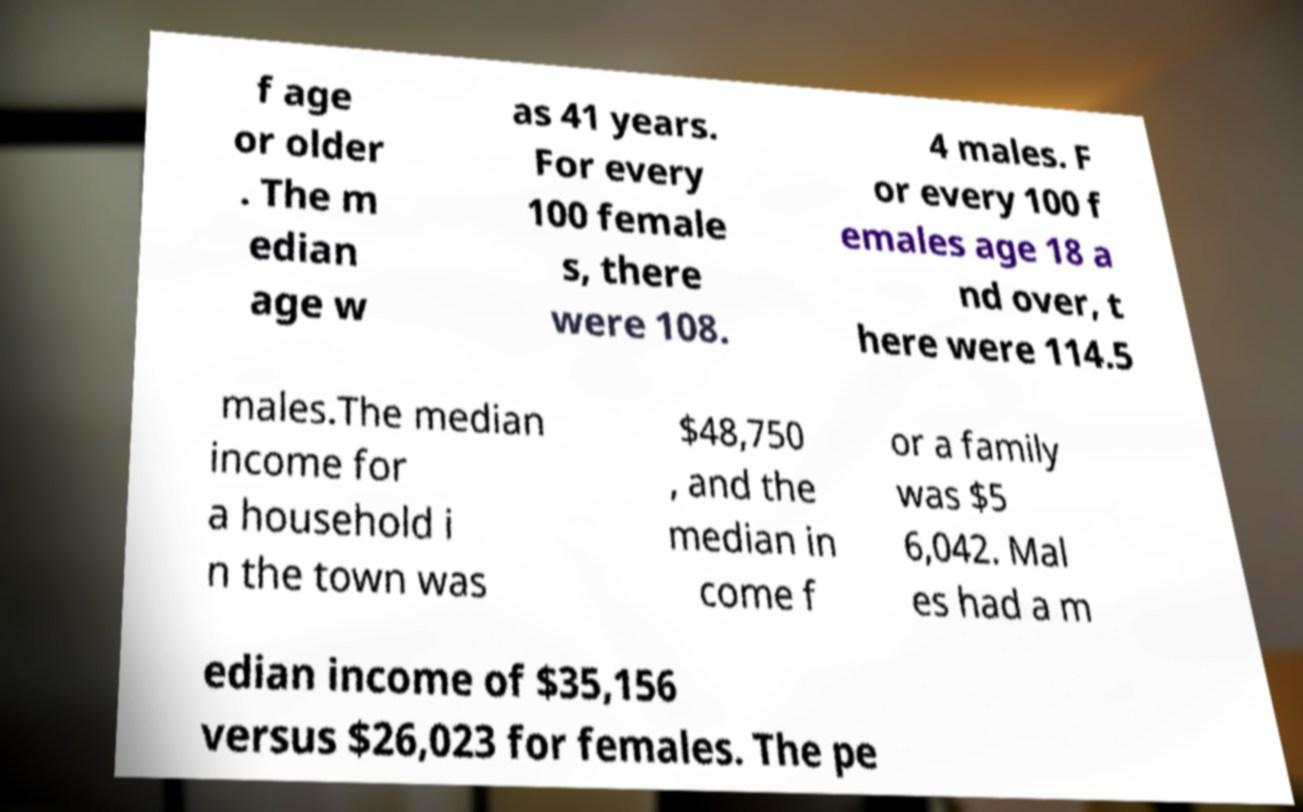For documentation purposes, I need the text within this image transcribed. Could you provide that? f age or older . The m edian age w as 41 years. For every 100 female s, there were 108. 4 males. F or every 100 f emales age 18 a nd over, t here were 114.5 males.The median income for a household i n the town was $48,750 , and the median in come f or a family was $5 6,042. Mal es had a m edian income of $35,156 versus $26,023 for females. The pe 